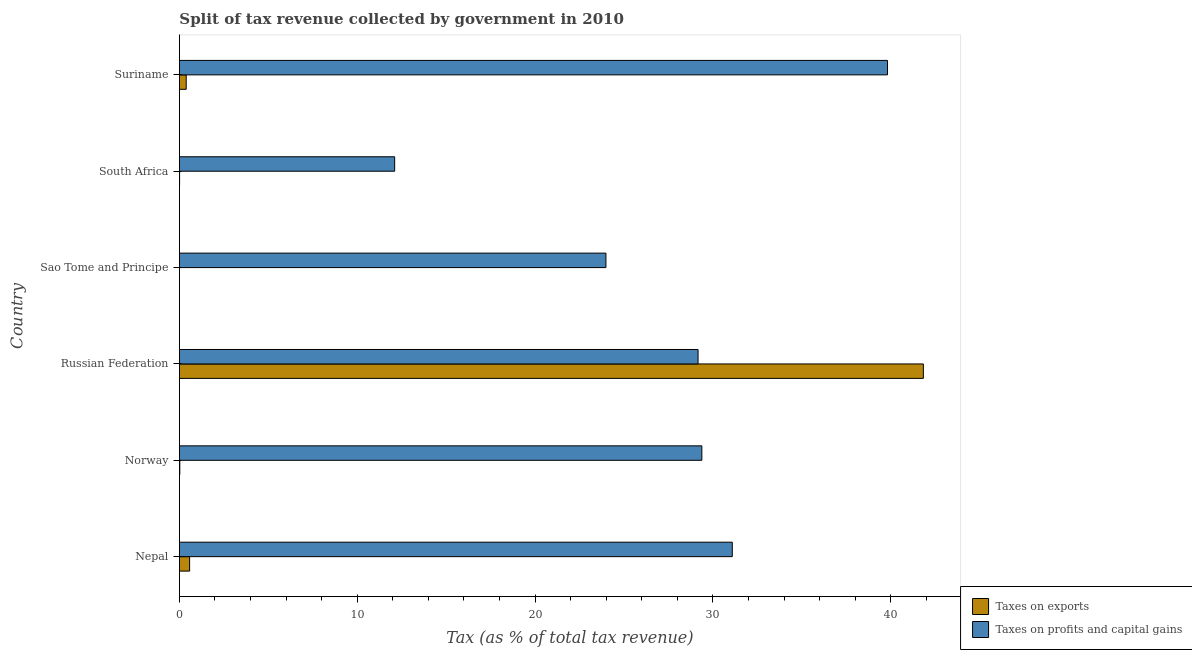How many different coloured bars are there?
Your response must be concise. 2. Are the number of bars per tick equal to the number of legend labels?
Offer a terse response. Yes. What is the label of the 4th group of bars from the top?
Provide a succinct answer. Russian Federation. In how many cases, is the number of bars for a given country not equal to the number of legend labels?
Keep it short and to the point. 0. What is the percentage of revenue obtained from taxes on exports in Norway?
Your answer should be very brief. 0.02. Across all countries, what is the maximum percentage of revenue obtained from taxes on profits and capital gains?
Offer a terse response. 39.82. Across all countries, what is the minimum percentage of revenue obtained from taxes on profits and capital gains?
Offer a very short reply. 12.1. In which country was the percentage of revenue obtained from taxes on exports maximum?
Give a very brief answer. Russian Federation. In which country was the percentage of revenue obtained from taxes on profits and capital gains minimum?
Your answer should be very brief. South Africa. What is the total percentage of revenue obtained from taxes on profits and capital gains in the graph?
Provide a short and direct response. 165.55. What is the difference between the percentage of revenue obtained from taxes on profits and capital gains in Norway and that in Suriname?
Offer a terse response. -10.44. What is the difference between the percentage of revenue obtained from taxes on profits and capital gains in Russian Federation and the percentage of revenue obtained from taxes on exports in Suriname?
Offer a very short reply. 28.79. What is the average percentage of revenue obtained from taxes on exports per country?
Offer a terse response. 7.14. What is the difference between the percentage of revenue obtained from taxes on exports and percentage of revenue obtained from taxes on profits and capital gains in Sao Tome and Principe?
Make the answer very short. -23.99. What is the ratio of the percentage of revenue obtained from taxes on profits and capital gains in Nepal to that in South Africa?
Ensure brevity in your answer.  2.57. Is the difference between the percentage of revenue obtained from taxes on exports in South Africa and Suriname greater than the difference between the percentage of revenue obtained from taxes on profits and capital gains in South Africa and Suriname?
Offer a very short reply. Yes. What is the difference between the highest and the second highest percentage of revenue obtained from taxes on profits and capital gains?
Provide a short and direct response. 8.73. What is the difference between the highest and the lowest percentage of revenue obtained from taxes on profits and capital gains?
Give a very brief answer. 27.72. In how many countries, is the percentage of revenue obtained from taxes on profits and capital gains greater than the average percentage of revenue obtained from taxes on profits and capital gains taken over all countries?
Your answer should be very brief. 4. Is the sum of the percentage of revenue obtained from taxes on profits and capital gains in Nepal and Sao Tome and Principe greater than the maximum percentage of revenue obtained from taxes on exports across all countries?
Your answer should be very brief. Yes. What does the 1st bar from the top in Russian Federation represents?
Provide a short and direct response. Taxes on profits and capital gains. What does the 1st bar from the bottom in South Africa represents?
Your response must be concise. Taxes on exports. How many bars are there?
Offer a terse response. 12. Are all the bars in the graph horizontal?
Give a very brief answer. Yes. How many countries are there in the graph?
Offer a terse response. 6. How many legend labels are there?
Your answer should be very brief. 2. What is the title of the graph?
Your answer should be very brief. Split of tax revenue collected by government in 2010. Does "Secondary school" appear as one of the legend labels in the graph?
Keep it short and to the point. No. What is the label or title of the X-axis?
Your response must be concise. Tax (as % of total tax revenue). What is the label or title of the Y-axis?
Your response must be concise. Country. What is the Tax (as % of total tax revenue) in Taxes on exports in Nepal?
Provide a short and direct response. 0.57. What is the Tax (as % of total tax revenue) in Taxes on profits and capital gains in Nepal?
Offer a terse response. 31.09. What is the Tax (as % of total tax revenue) in Taxes on exports in Norway?
Provide a succinct answer. 0.02. What is the Tax (as % of total tax revenue) of Taxes on profits and capital gains in Norway?
Keep it short and to the point. 29.38. What is the Tax (as % of total tax revenue) of Taxes on exports in Russian Federation?
Make the answer very short. 41.84. What is the Tax (as % of total tax revenue) in Taxes on profits and capital gains in Russian Federation?
Give a very brief answer. 29.17. What is the Tax (as % of total tax revenue) in Taxes on exports in Sao Tome and Principe?
Give a very brief answer. 0. What is the Tax (as % of total tax revenue) in Taxes on profits and capital gains in Sao Tome and Principe?
Provide a short and direct response. 23.99. What is the Tax (as % of total tax revenue) in Taxes on exports in South Africa?
Your answer should be compact. 0.01. What is the Tax (as % of total tax revenue) of Taxes on profits and capital gains in South Africa?
Offer a terse response. 12.1. What is the Tax (as % of total tax revenue) in Taxes on exports in Suriname?
Your response must be concise. 0.38. What is the Tax (as % of total tax revenue) in Taxes on profits and capital gains in Suriname?
Your answer should be compact. 39.82. Across all countries, what is the maximum Tax (as % of total tax revenue) of Taxes on exports?
Ensure brevity in your answer.  41.84. Across all countries, what is the maximum Tax (as % of total tax revenue) in Taxes on profits and capital gains?
Provide a short and direct response. 39.82. Across all countries, what is the minimum Tax (as % of total tax revenue) in Taxes on exports?
Your answer should be compact. 0. Across all countries, what is the minimum Tax (as % of total tax revenue) in Taxes on profits and capital gains?
Offer a terse response. 12.1. What is the total Tax (as % of total tax revenue) of Taxes on exports in the graph?
Your answer should be very brief. 42.82. What is the total Tax (as % of total tax revenue) in Taxes on profits and capital gains in the graph?
Offer a terse response. 165.55. What is the difference between the Tax (as % of total tax revenue) in Taxes on exports in Nepal and that in Norway?
Your response must be concise. 0.55. What is the difference between the Tax (as % of total tax revenue) in Taxes on profits and capital gains in Nepal and that in Norway?
Your response must be concise. 1.71. What is the difference between the Tax (as % of total tax revenue) in Taxes on exports in Nepal and that in Russian Federation?
Make the answer very short. -41.26. What is the difference between the Tax (as % of total tax revenue) in Taxes on profits and capital gains in Nepal and that in Russian Federation?
Provide a short and direct response. 1.92. What is the difference between the Tax (as % of total tax revenue) of Taxes on exports in Nepal and that in Sao Tome and Principe?
Keep it short and to the point. 0.57. What is the difference between the Tax (as % of total tax revenue) of Taxes on profits and capital gains in Nepal and that in Sao Tome and Principe?
Make the answer very short. 7.1. What is the difference between the Tax (as % of total tax revenue) of Taxes on exports in Nepal and that in South Africa?
Offer a very short reply. 0.56. What is the difference between the Tax (as % of total tax revenue) of Taxes on profits and capital gains in Nepal and that in South Africa?
Your response must be concise. 18.99. What is the difference between the Tax (as % of total tax revenue) of Taxes on exports in Nepal and that in Suriname?
Give a very brief answer. 0.19. What is the difference between the Tax (as % of total tax revenue) of Taxes on profits and capital gains in Nepal and that in Suriname?
Keep it short and to the point. -8.73. What is the difference between the Tax (as % of total tax revenue) of Taxes on exports in Norway and that in Russian Federation?
Your answer should be very brief. -41.82. What is the difference between the Tax (as % of total tax revenue) of Taxes on profits and capital gains in Norway and that in Russian Federation?
Offer a terse response. 0.21. What is the difference between the Tax (as % of total tax revenue) in Taxes on exports in Norway and that in Sao Tome and Principe?
Provide a short and direct response. 0.02. What is the difference between the Tax (as % of total tax revenue) in Taxes on profits and capital gains in Norway and that in Sao Tome and Principe?
Your response must be concise. 5.39. What is the difference between the Tax (as % of total tax revenue) in Taxes on exports in Norway and that in South Africa?
Ensure brevity in your answer.  0.01. What is the difference between the Tax (as % of total tax revenue) in Taxes on profits and capital gains in Norway and that in South Africa?
Give a very brief answer. 17.27. What is the difference between the Tax (as % of total tax revenue) of Taxes on exports in Norway and that in Suriname?
Your answer should be compact. -0.36. What is the difference between the Tax (as % of total tax revenue) of Taxes on profits and capital gains in Norway and that in Suriname?
Offer a very short reply. -10.44. What is the difference between the Tax (as % of total tax revenue) in Taxes on exports in Russian Federation and that in Sao Tome and Principe?
Offer a very short reply. 41.84. What is the difference between the Tax (as % of total tax revenue) of Taxes on profits and capital gains in Russian Federation and that in Sao Tome and Principe?
Give a very brief answer. 5.18. What is the difference between the Tax (as % of total tax revenue) in Taxes on exports in Russian Federation and that in South Africa?
Provide a succinct answer. 41.83. What is the difference between the Tax (as % of total tax revenue) in Taxes on profits and capital gains in Russian Federation and that in South Africa?
Offer a terse response. 17.06. What is the difference between the Tax (as % of total tax revenue) in Taxes on exports in Russian Federation and that in Suriname?
Make the answer very short. 41.46. What is the difference between the Tax (as % of total tax revenue) in Taxes on profits and capital gains in Russian Federation and that in Suriname?
Your response must be concise. -10.65. What is the difference between the Tax (as % of total tax revenue) in Taxes on exports in Sao Tome and Principe and that in South Africa?
Provide a succinct answer. -0.01. What is the difference between the Tax (as % of total tax revenue) of Taxes on profits and capital gains in Sao Tome and Principe and that in South Africa?
Ensure brevity in your answer.  11.88. What is the difference between the Tax (as % of total tax revenue) of Taxes on exports in Sao Tome and Principe and that in Suriname?
Give a very brief answer. -0.38. What is the difference between the Tax (as % of total tax revenue) in Taxes on profits and capital gains in Sao Tome and Principe and that in Suriname?
Provide a short and direct response. -15.83. What is the difference between the Tax (as % of total tax revenue) of Taxes on exports in South Africa and that in Suriname?
Offer a terse response. -0.37. What is the difference between the Tax (as % of total tax revenue) in Taxes on profits and capital gains in South Africa and that in Suriname?
Provide a short and direct response. -27.72. What is the difference between the Tax (as % of total tax revenue) in Taxes on exports in Nepal and the Tax (as % of total tax revenue) in Taxes on profits and capital gains in Norway?
Your answer should be very brief. -28.81. What is the difference between the Tax (as % of total tax revenue) in Taxes on exports in Nepal and the Tax (as % of total tax revenue) in Taxes on profits and capital gains in Russian Federation?
Ensure brevity in your answer.  -28.59. What is the difference between the Tax (as % of total tax revenue) of Taxes on exports in Nepal and the Tax (as % of total tax revenue) of Taxes on profits and capital gains in Sao Tome and Principe?
Make the answer very short. -23.41. What is the difference between the Tax (as % of total tax revenue) of Taxes on exports in Nepal and the Tax (as % of total tax revenue) of Taxes on profits and capital gains in South Africa?
Provide a short and direct response. -11.53. What is the difference between the Tax (as % of total tax revenue) of Taxes on exports in Nepal and the Tax (as % of total tax revenue) of Taxes on profits and capital gains in Suriname?
Give a very brief answer. -39.25. What is the difference between the Tax (as % of total tax revenue) in Taxes on exports in Norway and the Tax (as % of total tax revenue) in Taxes on profits and capital gains in Russian Federation?
Offer a terse response. -29.15. What is the difference between the Tax (as % of total tax revenue) in Taxes on exports in Norway and the Tax (as % of total tax revenue) in Taxes on profits and capital gains in Sao Tome and Principe?
Keep it short and to the point. -23.96. What is the difference between the Tax (as % of total tax revenue) of Taxes on exports in Norway and the Tax (as % of total tax revenue) of Taxes on profits and capital gains in South Africa?
Your answer should be compact. -12.08. What is the difference between the Tax (as % of total tax revenue) of Taxes on exports in Norway and the Tax (as % of total tax revenue) of Taxes on profits and capital gains in Suriname?
Provide a succinct answer. -39.8. What is the difference between the Tax (as % of total tax revenue) of Taxes on exports in Russian Federation and the Tax (as % of total tax revenue) of Taxes on profits and capital gains in Sao Tome and Principe?
Ensure brevity in your answer.  17.85. What is the difference between the Tax (as % of total tax revenue) in Taxes on exports in Russian Federation and the Tax (as % of total tax revenue) in Taxes on profits and capital gains in South Africa?
Offer a terse response. 29.73. What is the difference between the Tax (as % of total tax revenue) of Taxes on exports in Russian Federation and the Tax (as % of total tax revenue) of Taxes on profits and capital gains in Suriname?
Make the answer very short. 2.02. What is the difference between the Tax (as % of total tax revenue) of Taxes on exports in Sao Tome and Principe and the Tax (as % of total tax revenue) of Taxes on profits and capital gains in South Africa?
Offer a very short reply. -12.1. What is the difference between the Tax (as % of total tax revenue) of Taxes on exports in Sao Tome and Principe and the Tax (as % of total tax revenue) of Taxes on profits and capital gains in Suriname?
Your answer should be very brief. -39.82. What is the difference between the Tax (as % of total tax revenue) of Taxes on exports in South Africa and the Tax (as % of total tax revenue) of Taxes on profits and capital gains in Suriname?
Give a very brief answer. -39.81. What is the average Tax (as % of total tax revenue) in Taxes on exports per country?
Your answer should be very brief. 7.14. What is the average Tax (as % of total tax revenue) of Taxes on profits and capital gains per country?
Your response must be concise. 27.59. What is the difference between the Tax (as % of total tax revenue) of Taxes on exports and Tax (as % of total tax revenue) of Taxes on profits and capital gains in Nepal?
Keep it short and to the point. -30.52. What is the difference between the Tax (as % of total tax revenue) of Taxes on exports and Tax (as % of total tax revenue) of Taxes on profits and capital gains in Norway?
Give a very brief answer. -29.36. What is the difference between the Tax (as % of total tax revenue) of Taxes on exports and Tax (as % of total tax revenue) of Taxes on profits and capital gains in Russian Federation?
Your answer should be very brief. 12.67. What is the difference between the Tax (as % of total tax revenue) in Taxes on exports and Tax (as % of total tax revenue) in Taxes on profits and capital gains in Sao Tome and Principe?
Keep it short and to the point. -23.99. What is the difference between the Tax (as % of total tax revenue) of Taxes on exports and Tax (as % of total tax revenue) of Taxes on profits and capital gains in South Africa?
Make the answer very short. -12.09. What is the difference between the Tax (as % of total tax revenue) of Taxes on exports and Tax (as % of total tax revenue) of Taxes on profits and capital gains in Suriname?
Your answer should be very brief. -39.44. What is the ratio of the Tax (as % of total tax revenue) of Taxes on exports in Nepal to that in Norway?
Your response must be concise. 26.46. What is the ratio of the Tax (as % of total tax revenue) of Taxes on profits and capital gains in Nepal to that in Norway?
Your answer should be compact. 1.06. What is the ratio of the Tax (as % of total tax revenue) in Taxes on exports in Nepal to that in Russian Federation?
Provide a succinct answer. 0.01. What is the ratio of the Tax (as % of total tax revenue) of Taxes on profits and capital gains in Nepal to that in Russian Federation?
Make the answer very short. 1.07. What is the ratio of the Tax (as % of total tax revenue) in Taxes on exports in Nepal to that in Sao Tome and Principe?
Your answer should be compact. 651.05. What is the ratio of the Tax (as % of total tax revenue) of Taxes on profits and capital gains in Nepal to that in Sao Tome and Principe?
Offer a very short reply. 1.3. What is the ratio of the Tax (as % of total tax revenue) of Taxes on exports in Nepal to that in South Africa?
Your answer should be very brief. 56.01. What is the ratio of the Tax (as % of total tax revenue) of Taxes on profits and capital gains in Nepal to that in South Africa?
Make the answer very short. 2.57. What is the ratio of the Tax (as % of total tax revenue) in Taxes on exports in Nepal to that in Suriname?
Give a very brief answer. 1.5. What is the ratio of the Tax (as % of total tax revenue) of Taxes on profits and capital gains in Nepal to that in Suriname?
Offer a terse response. 0.78. What is the ratio of the Tax (as % of total tax revenue) of Taxes on profits and capital gains in Norway to that in Russian Federation?
Provide a short and direct response. 1.01. What is the ratio of the Tax (as % of total tax revenue) in Taxes on exports in Norway to that in Sao Tome and Principe?
Provide a succinct answer. 24.61. What is the ratio of the Tax (as % of total tax revenue) of Taxes on profits and capital gains in Norway to that in Sao Tome and Principe?
Your response must be concise. 1.22. What is the ratio of the Tax (as % of total tax revenue) in Taxes on exports in Norway to that in South Africa?
Offer a terse response. 2.12. What is the ratio of the Tax (as % of total tax revenue) in Taxes on profits and capital gains in Norway to that in South Africa?
Offer a very short reply. 2.43. What is the ratio of the Tax (as % of total tax revenue) in Taxes on exports in Norway to that in Suriname?
Give a very brief answer. 0.06. What is the ratio of the Tax (as % of total tax revenue) of Taxes on profits and capital gains in Norway to that in Suriname?
Your answer should be compact. 0.74. What is the ratio of the Tax (as % of total tax revenue) in Taxes on exports in Russian Federation to that in Sao Tome and Principe?
Provide a succinct answer. 4.75e+04. What is the ratio of the Tax (as % of total tax revenue) in Taxes on profits and capital gains in Russian Federation to that in Sao Tome and Principe?
Provide a succinct answer. 1.22. What is the ratio of the Tax (as % of total tax revenue) in Taxes on exports in Russian Federation to that in South Africa?
Offer a terse response. 4090.06. What is the ratio of the Tax (as % of total tax revenue) of Taxes on profits and capital gains in Russian Federation to that in South Africa?
Provide a short and direct response. 2.41. What is the ratio of the Tax (as % of total tax revenue) of Taxes on exports in Russian Federation to that in Suriname?
Provide a short and direct response. 109.69. What is the ratio of the Tax (as % of total tax revenue) in Taxes on profits and capital gains in Russian Federation to that in Suriname?
Your answer should be compact. 0.73. What is the ratio of the Tax (as % of total tax revenue) of Taxes on exports in Sao Tome and Principe to that in South Africa?
Provide a short and direct response. 0.09. What is the ratio of the Tax (as % of total tax revenue) of Taxes on profits and capital gains in Sao Tome and Principe to that in South Africa?
Offer a very short reply. 1.98. What is the ratio of the Tax (as % of total tax revenue) in Taxes on exports in Sao Tome and Principe to that in Suriname?
Your answer should be compact. 0. What is the ratio of the Tax (as % of total tax revenue) in Taxes on profits and capital gains in Sao Tome and Principe to that in Suriname?
Ensure brevity in your answer.  0.6. What is the ratio of the Tax (as % of total tax revenue) in Taxes on exports in South Africa to that in Suriname?
Offer a terse response. 0.03. What is the ratio of the Tax (as % of total tax revenue) of Taxes on profits and capital gains in South Africa to that in Suriname?
Your answer should be very brief. 0.3. What is the difference between the highest and the second highest Tax (as % of total tax revenue) of Taxes on exports?
Keep it short and to the point. 41.26. What is the difference between the highest and the second highest Tax (as % of total tax revenue) of Taxes on profits and capital gains?
Your response must be concise. 8.73. What is the difference between the highest and the lowest Tax (as % of total tax revenue) in Taxes on exports?
Keep it short and to the point. 41.84. What is the difference between the highest and the lowest Tax (as % of total tax revenue) of Taxes on profits and capital gains?
Keep it short and to the point. 27.72. 